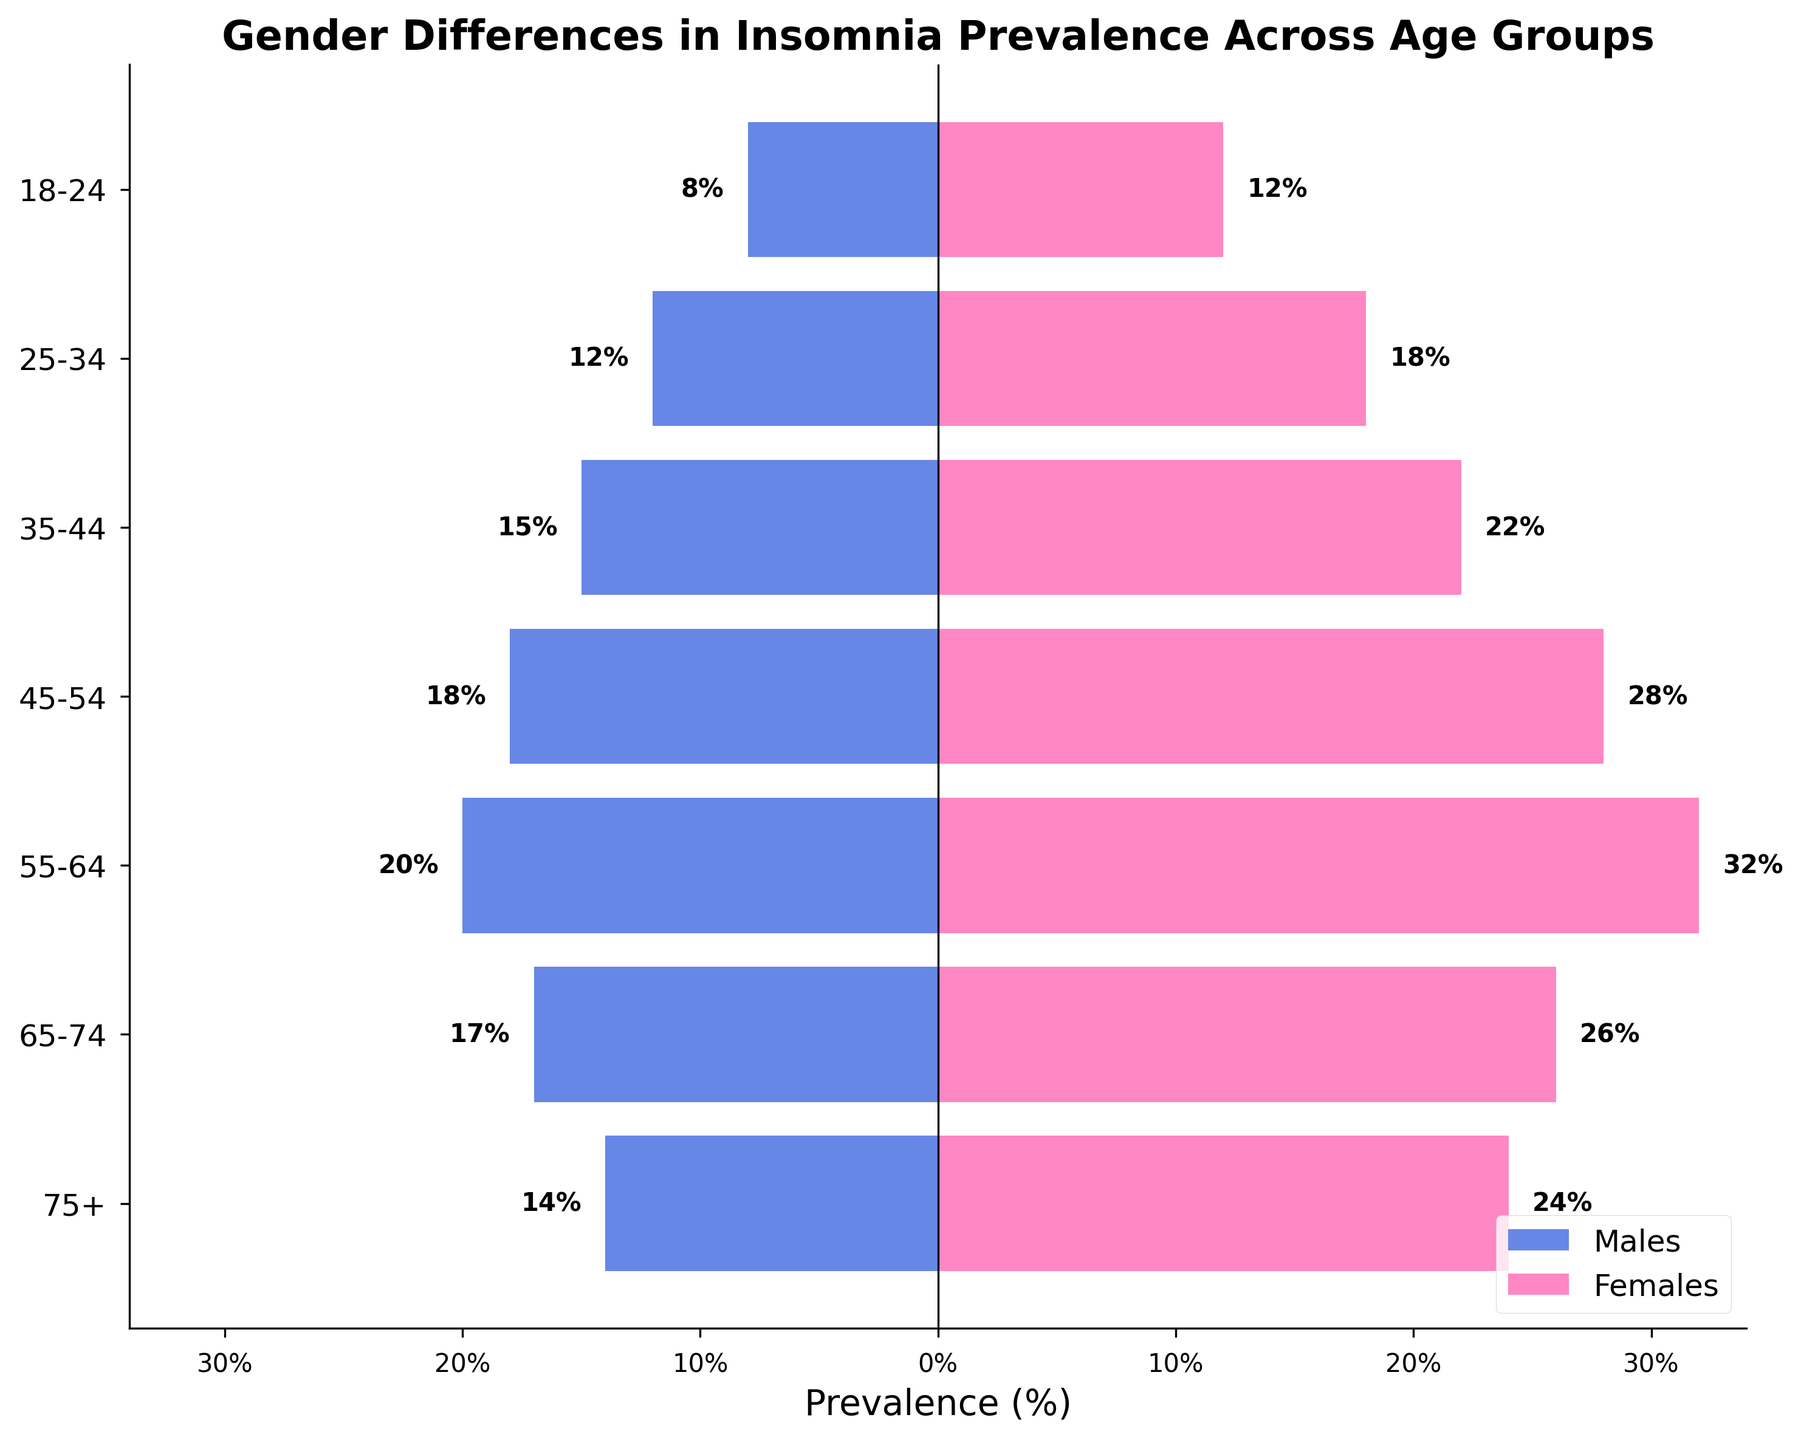what is the title of the plot? The title is located at the top of the figure, usually in bold and larger font size compared to other text. The title provides a summary of what the plot represents.
Answer: Gender Differences in Insomnia Prevalence Across Age Groups What are the colors used to represent males and females? The colors in the plot distinguish the two genders. Males are represented with blue bars, and females with pink bars. This can be inferred by looking at the legend in the lower right corner.
Answer: Blue and Pink In which age group do males have the highest prevalence of insomnia? By observing the left-side horizontal bars representing males, the longest bar indicates the highest prevalence. The age group with a prevalence of 20% is 55-64 years.
Answer: 55-64 What's the difference in the prevalence of insomnia between males and females aged 35-44? In the age group 35-44, males have a prevalence of 15%, while females have 22%. The difference can be calculated as 22% - 15% = 7%.
Answer: 7% In which age group do females have the highest prevalence of insomnia? By looking at the right-side horizontal bars for females, the longest bar represents the highest prevalence. Females aged 55-64 have the highest prevalence of 32%.
Answer: 55-64 Which gender has a greater prevalence of insomnia in the 18-24 age group, and by how much? For the age group 18-24, females have a prevalence of 12%, and males have 8%. Comparing these values, females have a higher prevalence by 4%.
Answer: Females, by 4% What is the overall trend of insomnia prevalence for both genders as age increases? Observing the length of the bars for both genders as we move from the youngest to the oldest age groups, we notice an increasing trend in prevalence, peaking at middle age for both, and slightly decreasing for older ages.
Answer: Increasing, then decreasing slightly in older age How does the prevalence of insomnia in the youngest age group for males compare to that in the oldest age group for males? Comparing the lengths of the bars for the youngest (18-24) and oldest (75+) age groups for males, the prevalence is 8% for 18-24 and 14% for 75+. The oldest group has a higher prevalence by 6%.
Answer: Higher by 6% What is the difference in the prevalence of insomnia between the age groups 65-74 and 75+ for females? The prevalence for females aged 65-74 is 26%, and for 75+, it is 24%. The difference can be calculated as 26% - 24% = 2%.
Answer: 2% Which age group shows the smallest gender difference in insomnia prevalence? To find the smallest gender difference, compare the difference between male and female prevalence for each age group. The smallest difference is in the 18-24 age group, where the difference is 4% (12% - 8%).
Answer: 18-24 